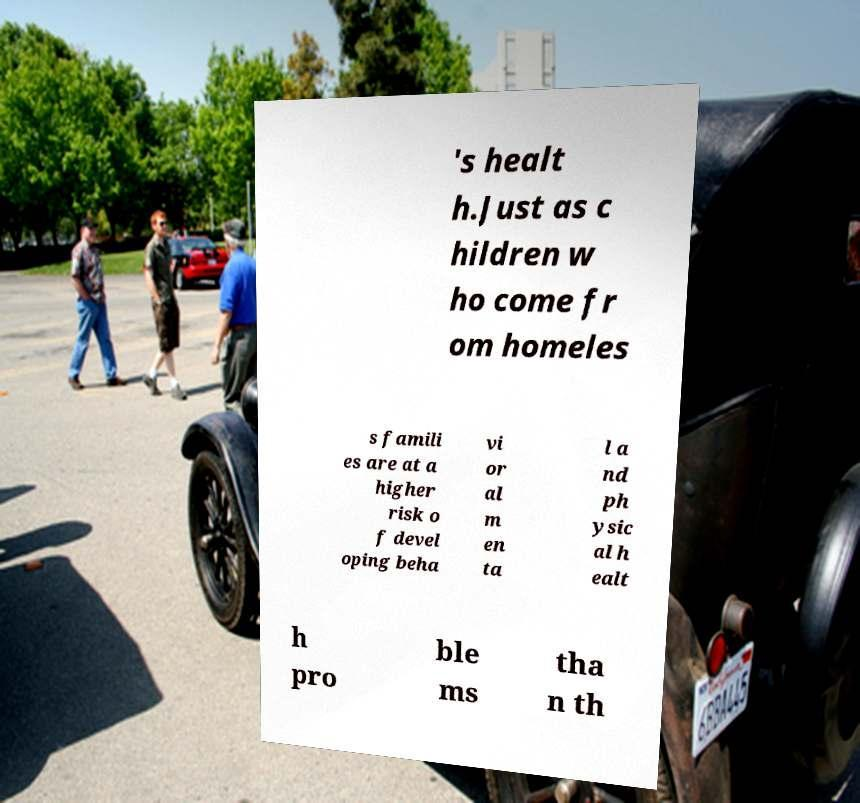Could you extract and type out the text from this image? 's healt h.Just as c hildren w ho come fr om homeles s famili es are at a higher risk o f devel oping beha vi or al m en ta l a nd ph ysic al h ealt h pro ble ms tha n th 